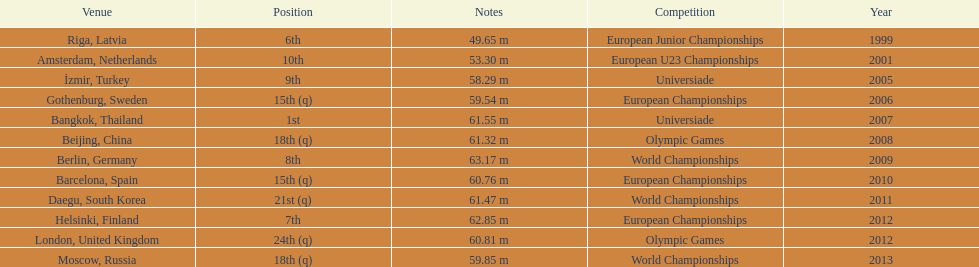How many world championships has he been in? 3. 